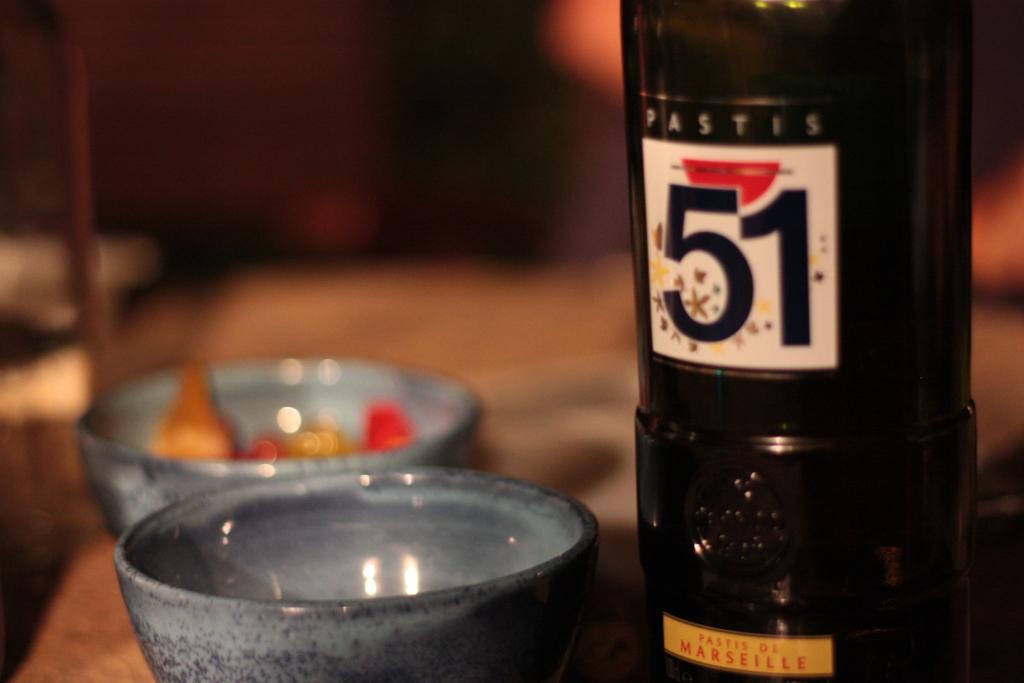What is the name of the beer?
Offer a terse response. Pastis 51. Where does this wine come from, according to the yellow strip on the label?
Your answer should be very brief. Marseille. 